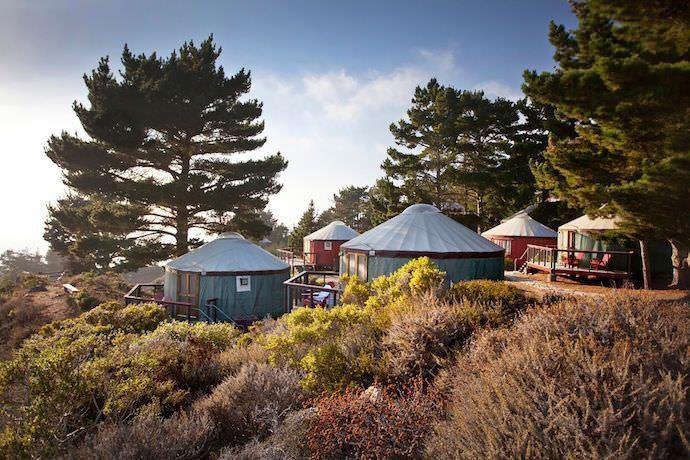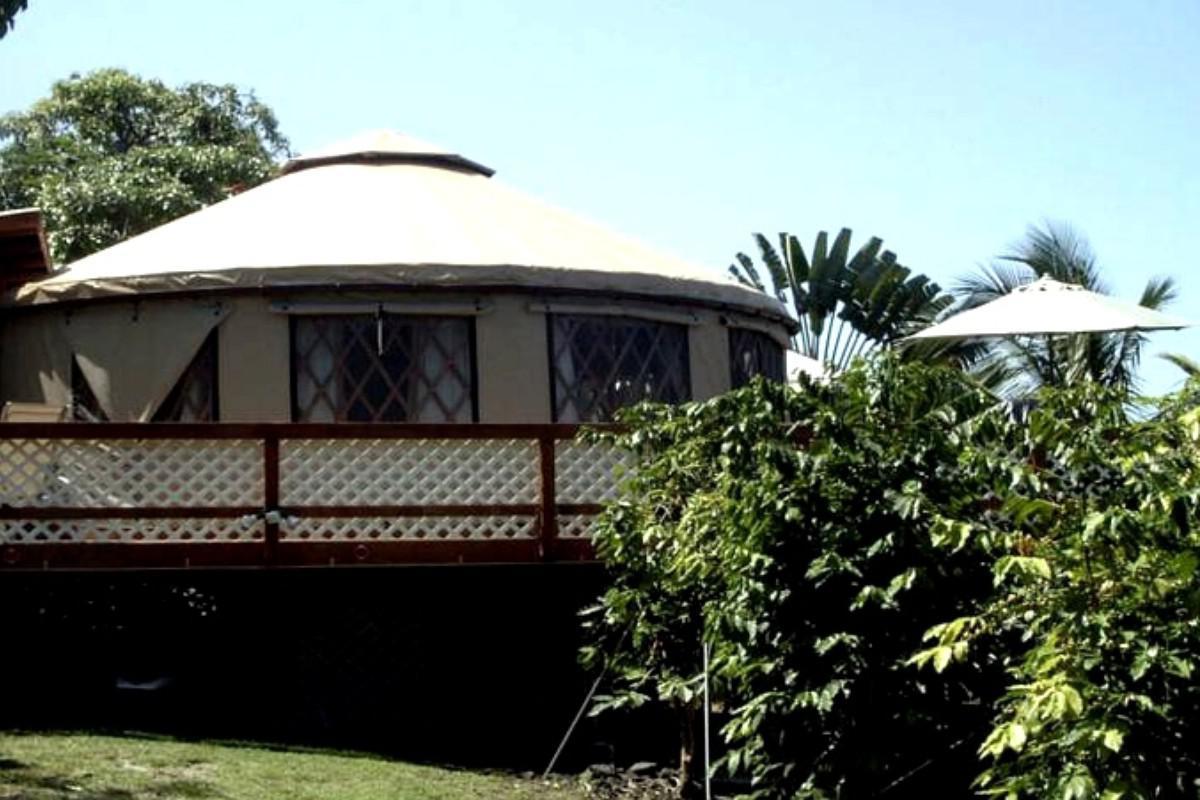The first image is the image on the left, the second image is the image on the right. Given the left and right images, does the statement "There are four or more yurts in the left image and some of them are red." hold true? Answer yes or no. Yes. 